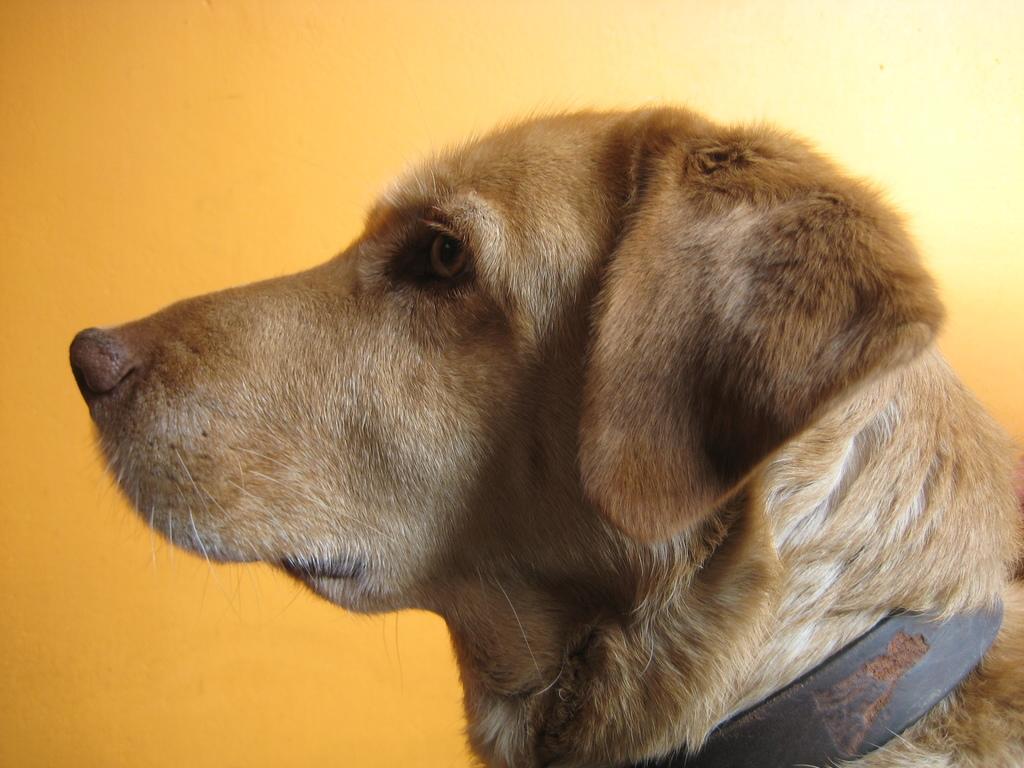Describe this image in one or two sentences. In this image, we can see a dog, in the background, we can see the yellow wall. 